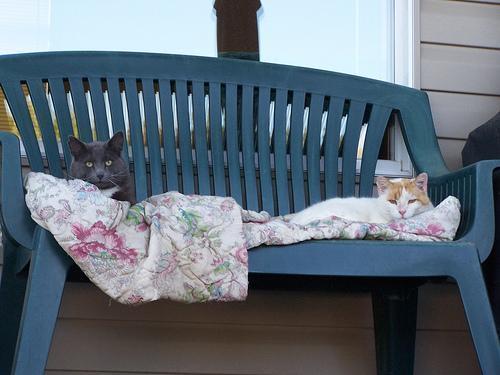What kind of prey do these animals hunt?
Select the accurate response from the four choices given to answer the question.
Options: Large, deer, small, bears. Small. 